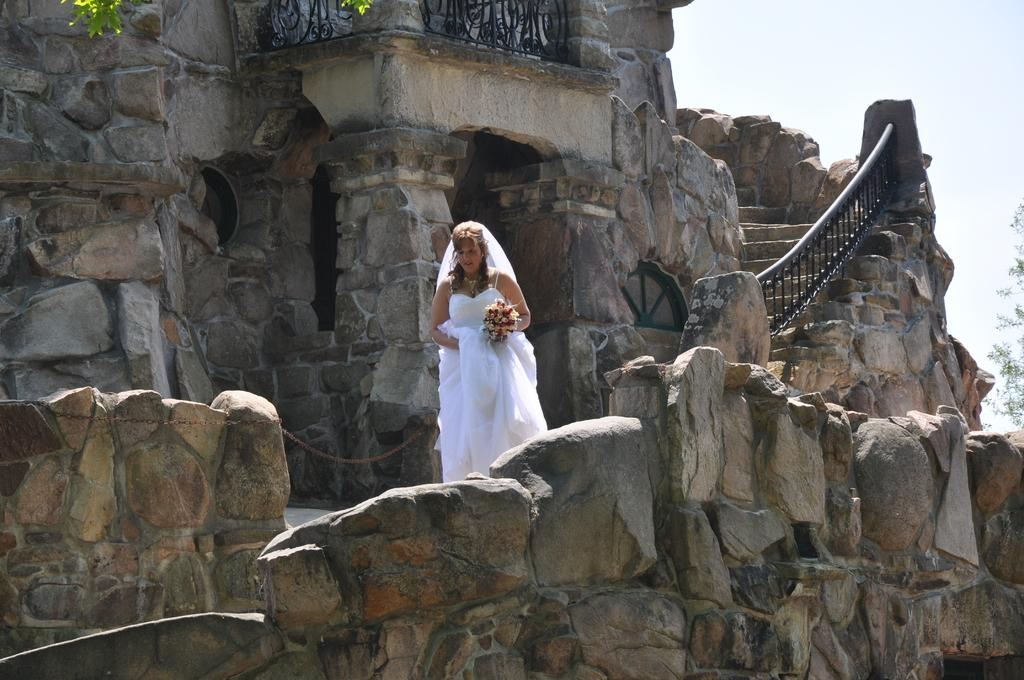Who is present in the image? There is a woman in the image. What is the woman holding in the image? The woman is holding a flower bouquet. Where is the image set? The image is set in a building. What can be seen on the left side of the image? There is a tree on the left side of the image. Can you see a tiger swimming in the image? No, there is no tiger or swimming activity present in the image. 